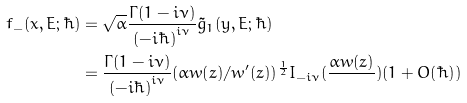Convert formula to latex. <formula><loc_0><loc_0><loc_500><loc_500>f _ { - } ( x , E ; \hbar { ) } & = \sqrt { \alpha } \frac { \Gamma ( 1 - i \nu ) } { ( - i \hbar { ) } ^ { i \nu } } \tilde { g } _ { 1 } ( y , E ; \hbar { ) } \\ & = \frac { \Gamma ( 1 - i \nu ) } { ( - i \hbar { ) } ^ { i \nu } } ( \alpha w ( z ) / w ^ { \prime } ( z ) ) ^ { \frac { 1 } { 2 } } I _ { - i \nu } ( \frac { \alpha w ( z ) } { } ) ( 1 + O ( \hbar { ) } )</formula> 